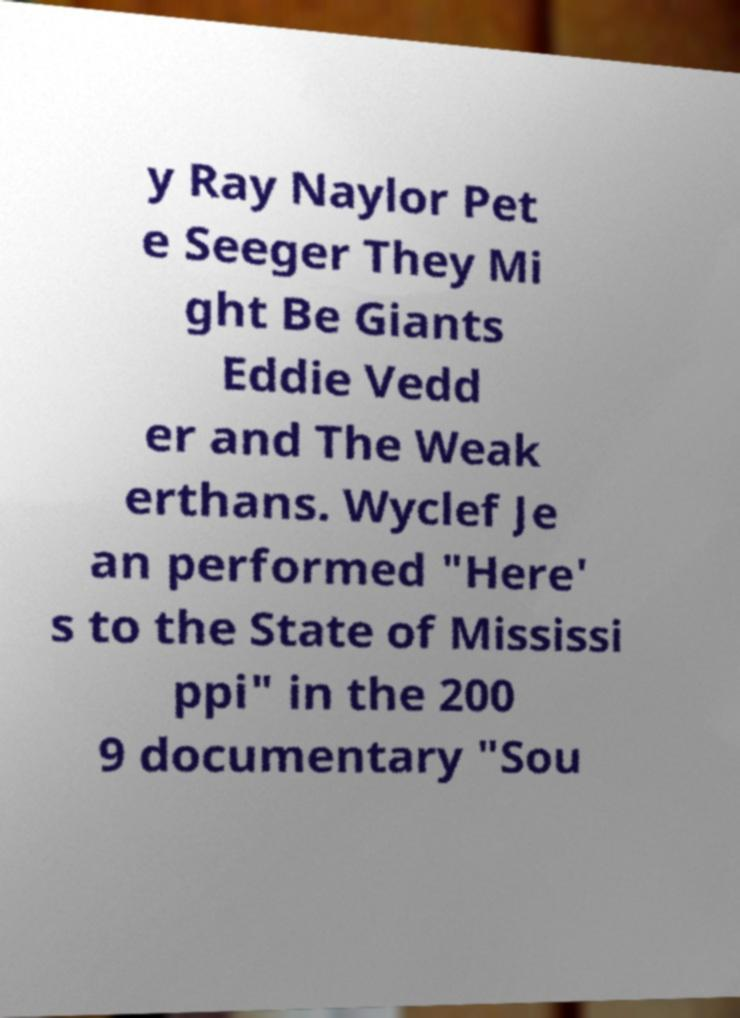Can you read and provide the text displayed in the image?This photo seems to have some interesting text. Can you extract and type it out for me? y Ray Naylor Pet e Seeger They Mi ght Be Giants Eddie Vedd er and The Weak erthans. Wyclef Je an performed "Here' s to the State of Mississi ppi" in the 200 9 documentary "Sou 